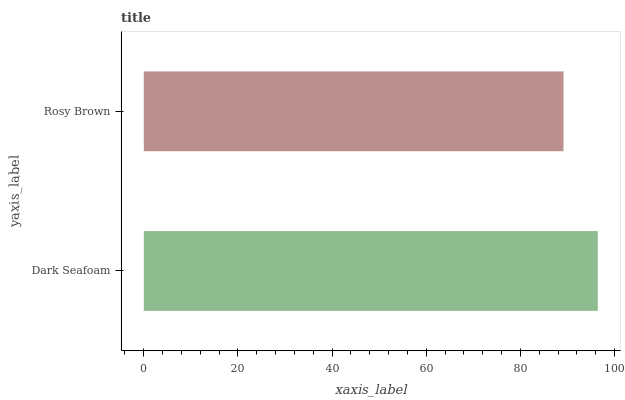Is Rosy Brown the minimum?
Answer yes or no. Yes. Is Dark Seafoam the maximum?
Answer yes or no. Yes. Is Rosy Brown the maximum?
Answer yes or no. No. Is Dark Seafoam greater than Rosy Brown?
Answer yes or no. Yes. Is Rosy Brown less than Dark Seafoam?
Answer yes or no. Yes. Is Rosy Brown greater than Dark Seafoam?
Answer yes or no. No. Is Dark Seafoam less than Rosy Brown?
Answer yes or no. No. Is Dark Seafoam the high median?
Answer yes or no. Yes. Is Rosy Brown the low median?
Answer yes or no. Yes. Is Rosy Brown the high median?
Answer yes or no. No. Is Dark Seafoam the low median?
Answer yes or no. No. 